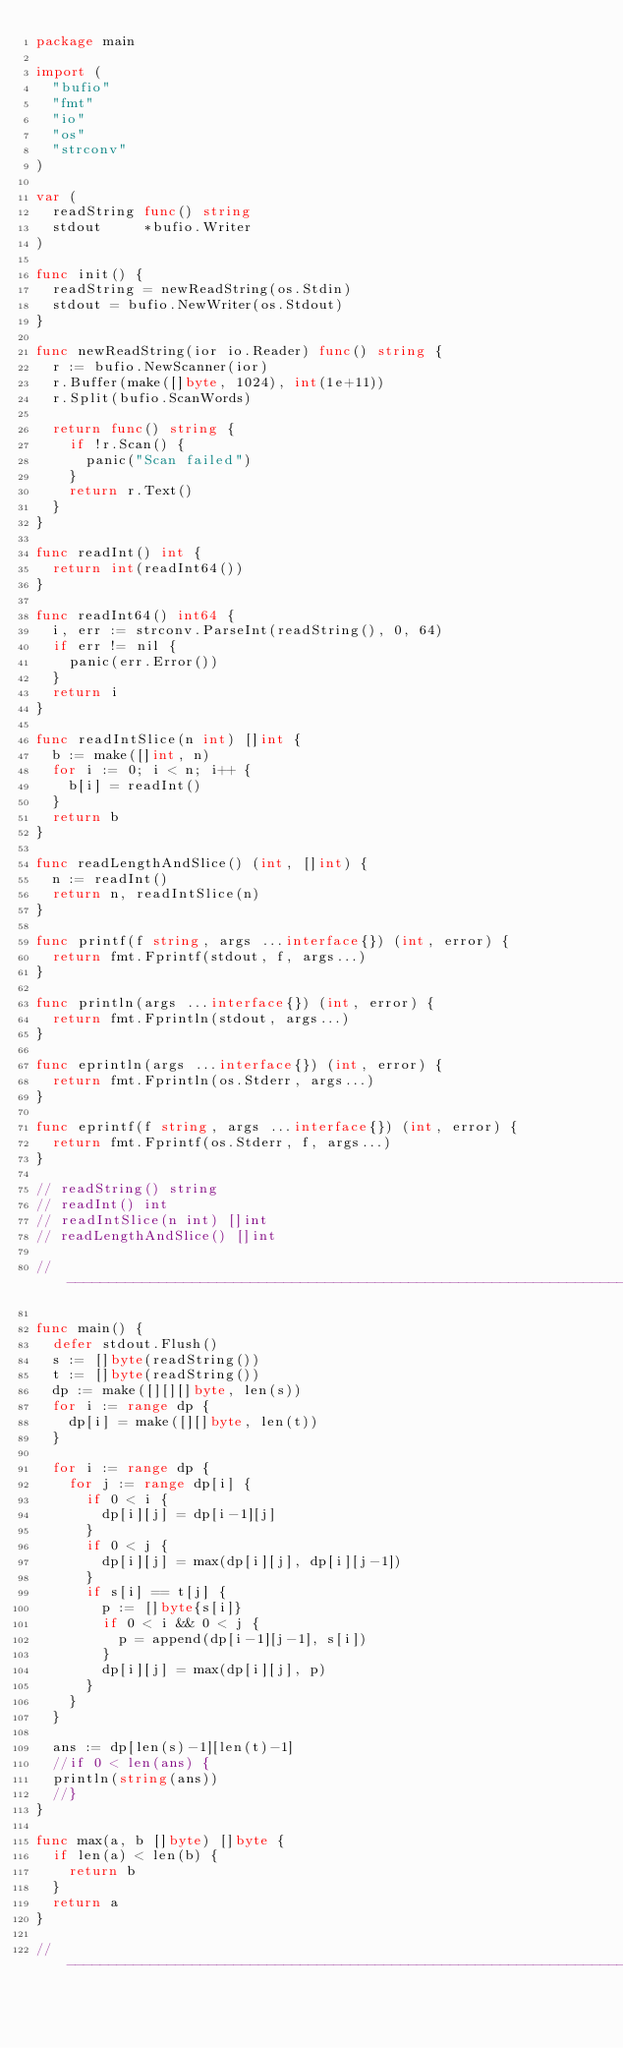<code> <loc_0><loc_0><loc_500><loc_500><_Go_>package main

import (
	"bufio"
	"fmt"
	"io"
	"os"
	"strconv"
)

var (
	readString func() string
	stdout     *bufio.Writer
)

func init() {
	readString = newReadString(os.Stdin)
	stdout = bufio.NewWriter(os.Stdout)
}

func newReadString(ior io.Reader) func() string {
	r := bufio.NewScanner(ior)
	r.Buffer(make([]byte, 1024), int(1e+11))
	r.Split(bufio.ScanWords)

	return func() string {
		if !r.Scan() {
			panic("Scan failed")
		}
		return r.Text()
	}
}

func readInt() int {
	return int(readInt64())
}

func readInt64() int64 {
	i, err := strconv.ParseInt(readString(), 0, 64)
	if err != nil {
		panic(err.Error())
	}
	return i
}

func readIntSlice(n int) []int {
	b := make([]int, n)
	for i := 0; i < n; i++ {
		b[i] = readInt()
	}
	return b
}

func readLengthAndSlice() (int, []int) {
	n := readInt()
	return n, readIntSlice(n)
}

func printf(f string, args ...interface{}) (int, error) {
	return fmt.Fprintf(stdout, f, args...)
}

func println(args ...interface{}) (int, error) {
	return fmt.Fprintln(stdout, args...)
}

func eprintln(args ...interface{}) (int, error) {
	return fmt.Fprintln(os.Stderr, args...)
}

func eprintf(f string, args ...interface{}) (int, error) {
	return fmt.Fprintf(os.Stderr, f, args...)
}

// readString() string
// readInt() int
// readIntSlice(n int) []int
// readLengthAndSlice() []int

// -----------------------------------------------------------------------------

func main() {
	defer stdout.Flush()
	s := []byte(readString())
	t := []byte(readString())
	dp := make([][][]byte, len(s))
	for i := range dp {
		dp[i] = make([][]byte, len(t))
	}

	for i := range dp {
		for j := range dp[i] {
			if 0 < i {
				dp[i][j] = dp[i-1][j]
			}
			if 0 < j {
				dp[i][j] = max(dp[i][j], dp[i][j-1])
			}
			if s[i] == t[j] {
				p := []byte{s[i]}
				if 0 < i && 0 < j {
					p = append(dp[i-1][j-1], s[i])
				}
				dp[i][j] = max(dp[i][j], p)
			}
		}
	}

	ans := dp[len(s)-1][len(t)-1]
	//if 0 < len(ans) {
	println(string(ans))
	//}
}

func max(a, b []byte) []byte {
	if len(a) < len(b) {
		return b
	}
	return a
}

// -----------------------------------------------------------------------------
</code> 